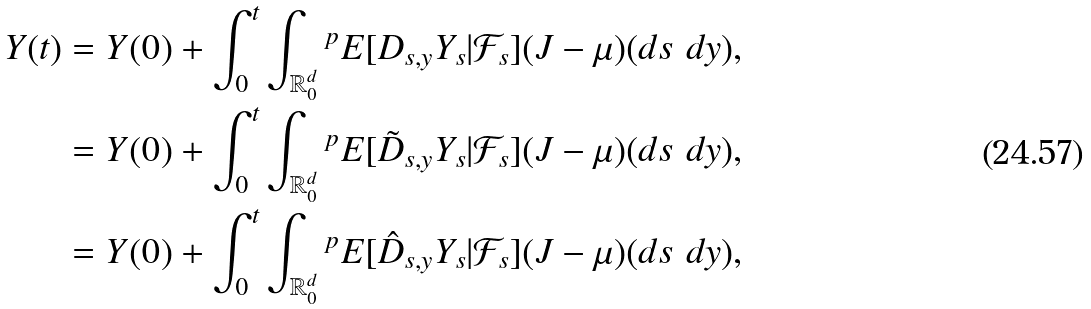Convert formula to latex. <formula><loc_0><loc_0><loc_500><loc_500>Y ( t ) & = Y ( 0 ) + \int _ { 0 } ^ { t } \int _ { \mathbb { R } ^ { d } _ { 0 } } { ^ { p } } E [ D _ { s , y } Y _ { s } | \mathcal { F } _ { s } ] ( J - \mu ) ( d s \ d y ) , \\ & = Y ( 0 ) + \int _ { 0 } ^ { t } \int _ { \mathbb { R } ^ { d } _ { 0 } } { ^ { p } } E [ \tilde { D } _ { s , y } Y _ { s } | \mathcal { F } _ { s } ] ( J - \mu ) ( d s \ d y ) , \\ & = Y ( 0 ) + \int _ { 0 } ^ { t } \int _ { \mathbb { R } ^ { d } _ { 0 } } { ^ { p } } E [ \hat { D } _ { s , y } Y _ { s } | \mathcal { F } _ { s } ] ( J - \mu ) ( d s \ d y ) ,</formula> 